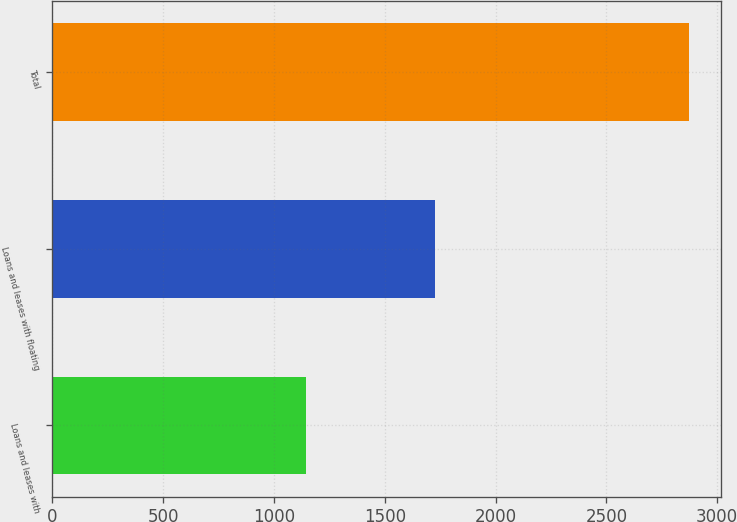Convert chart to OTSL. <chart><loc_0><loc_0><loc_500><loc_500><bar_chart><fcel>Loans and leases with<fcel>Loans and leases with floating<fcel>Total<nl><fcel>1145<fcel>1728<fcel>2873<nl></chart> 